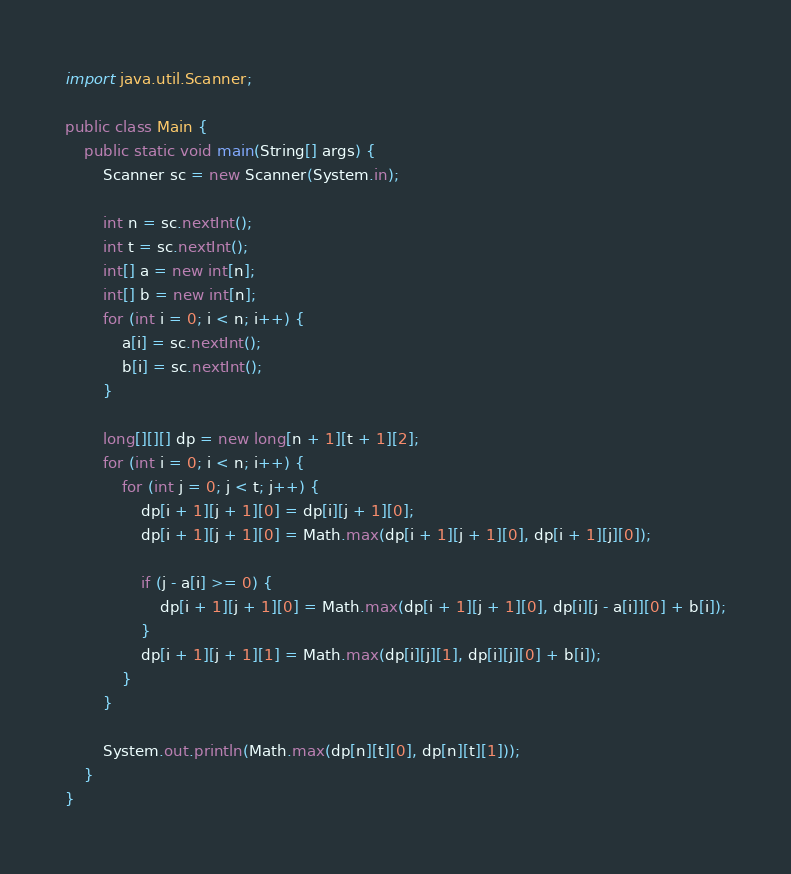<code> <loc_0><loc_0><loc_500><loc_500><_Java_>import java.util.Scanner;

public class Main {
	public static void main(String[] args) {
		Scanner sc = new Scanner(System.in);

		int n = sc.nextInt();
		int t = sc.nextInt();
		int[] a = new int[n];
		int[] b = new int[n];
		for (int i = 0; i < n; i++) {
			a[i] = sc.nextInt();
			b[i] = sc.nextInt();
		}

		long[][][] dp = new long[n + 1][t + 1][2];
		for (int i = 0; i < n; i++) {
			for (int j = 0; j < t; j++) {
				dp[i + 1][j + 1][0] = dp[i][j + 1][0];
				dp[i + 1][j + 1][0] = Math.max(dp[i + 1][j + 1][0], dp[i + 1][j][0]);

				if (j - a[i] >= 0) {
					dp[i + 1][j + 1][0] = Math.max(dp[i + 1][j + 1][0], dp[i][j - a[i]][0] + b[i]);
				}
				dp[i + 1][j + 1][1] = Math.max(dp[i][j][1], dp[i][j][0] + b[i]);
			}
		}

		System.out.println(Math.max(dp[n][t][0], dp[n][t][1]));
	}
}
</code> 